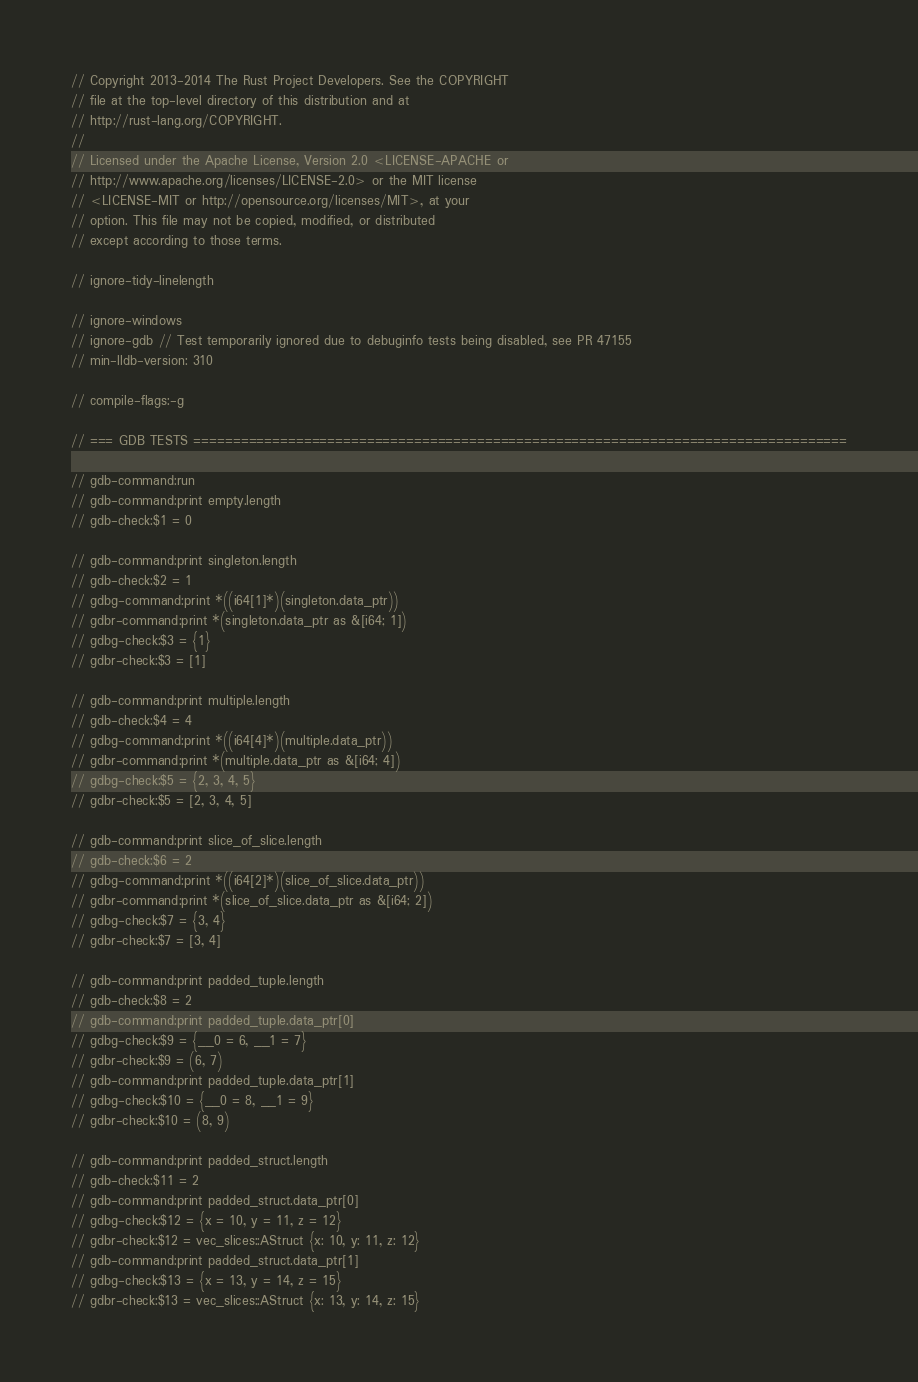<code> <loc_0><loc_0><loc_500><loc_500><_Rust_>// Copyright 2013-2014 The Rust Project Developers. See the COPYRIGHT
// file at the top-level directory of this distribution and at
// http://rust-lang.org/COPYRIGHT.
//
// Licensed under the Apache License, Version 2.0 <LICENSE-APACHE or
// http://www.apache.org/licenses/LICENSE-2.0> or the MIT license
// <LICENSE-MIT or http://opensource.org/licenses/MIT>, at your
// option. This file may not be copied, modified, or distributed
// except according to those terms.

// ignore-tidy-linelength

// ignore-windows
// ignore-gdb // Test temporarily ignored due to debuginfo tests being disabled, see PR 47155
// min-lldb-version: 310

// compile-flags:-g

// === GDB TESTS ===================================================================================

// gdb-command:run
// gdb-command:print empty.length
// gdb-check:$1 = 0

// gdb-command:print singleton.length
// gdb-check:$2 = 1
// gdbg-command:print *((i64[1]*)(singleton.data_ptr))
// gdbr-command:print *(singleton.data_ptr as &[i64; 1])
// gdbg-check:$3 = {1}
// gdbr-check:$3 = [1]

// gdb-command:print multiple.length
// gdb-check:$4 = 4
// gdbg-command:print *((i64[4]*)(multiple.data_ptr))
// gdbr-command:print *(multiple.data_ptr as &[i64; 4])
// gdbg-check:$5 = {2, 3, 4, 5}
// gdbr-check:$5 = [2, 3, 4, 5]

// gdb-command:print slice_of_slice.length
// gdb-check:$6 = 2
// gdbg-command:print *((i64[2]*)(slice_of_slice.data_ptr))
// gdbr-command:print *(slice_of_slice.data_ptr as &[i64; 2])
// gdbg-check:$7 = {3, 4}
// gdbr-check:$7 = [3, 4]

// gdb-command:print padded_tuple.length
// gdb-check:$8 = 2
// gdb-command:print padded_tuple.data_ptr[0]
// gdbg-check:$9 = {__0 = 6, __1 = 7}
// gdbr-check:$9 = (6, 7)
// gdb-command:print padded_tuple.data_ptr[1]
// gdbg-check:$10 = {__0 = 8, __1 = 9}
// gdbr-check:$10 = (8, 9)

// gdb-command:print padded_struct.length
// gdb-check:$11 = 2
// gdb-command:print padded_struct.data_ptr[0]
// gdbg-check:$12 = {x = 10, y = 11, z = 12}
// gdbr-check:$12 = vec_slices::AStruct {x: 10, y: 11, z: 12}
// gdb-command:print padded_struct.data_ptr[1]
// gdbg-check:$13 = {x = 13, y = 14, z = 15}
// gdbr-check:$13 = vec_slices::AStruct {x: 13, y: 14, z: 15}
</code> 